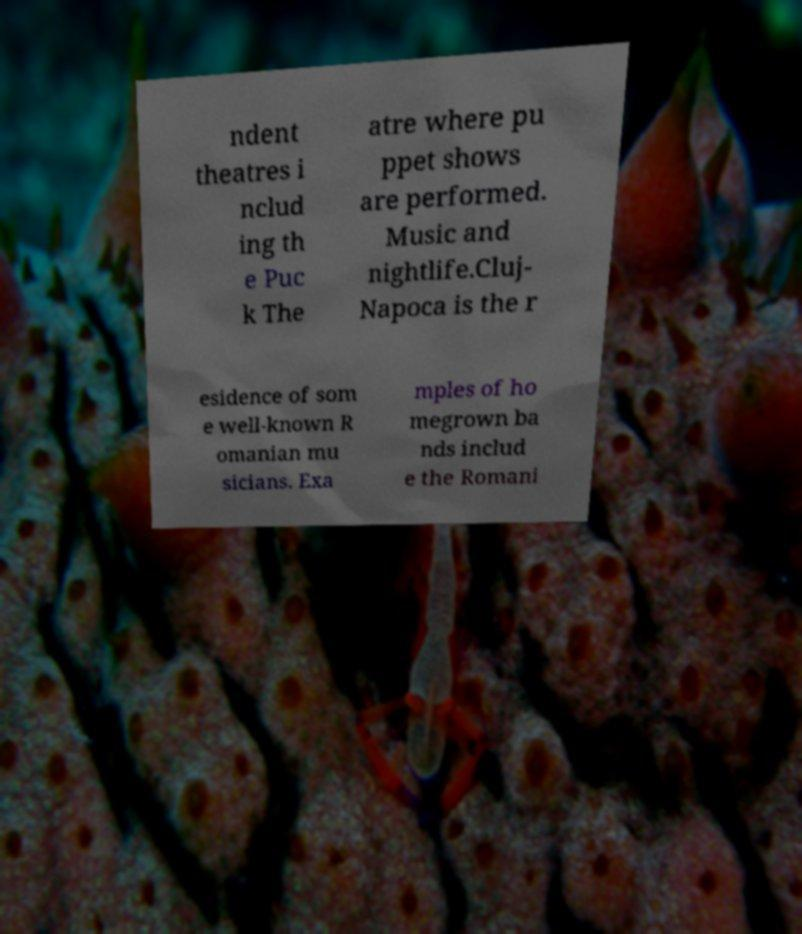There's text embedded in this image that I need extracted. Can you transcribe it verbatim? ndent theatres i nclud ing th e Puc k The atre where pu ppet shows are performed. Music and nightlife.Cluj- Napoca is the r esidence of som e well-known R omanian mu sicians. Exa mples of ho megrown ba nds includ e the Romani 